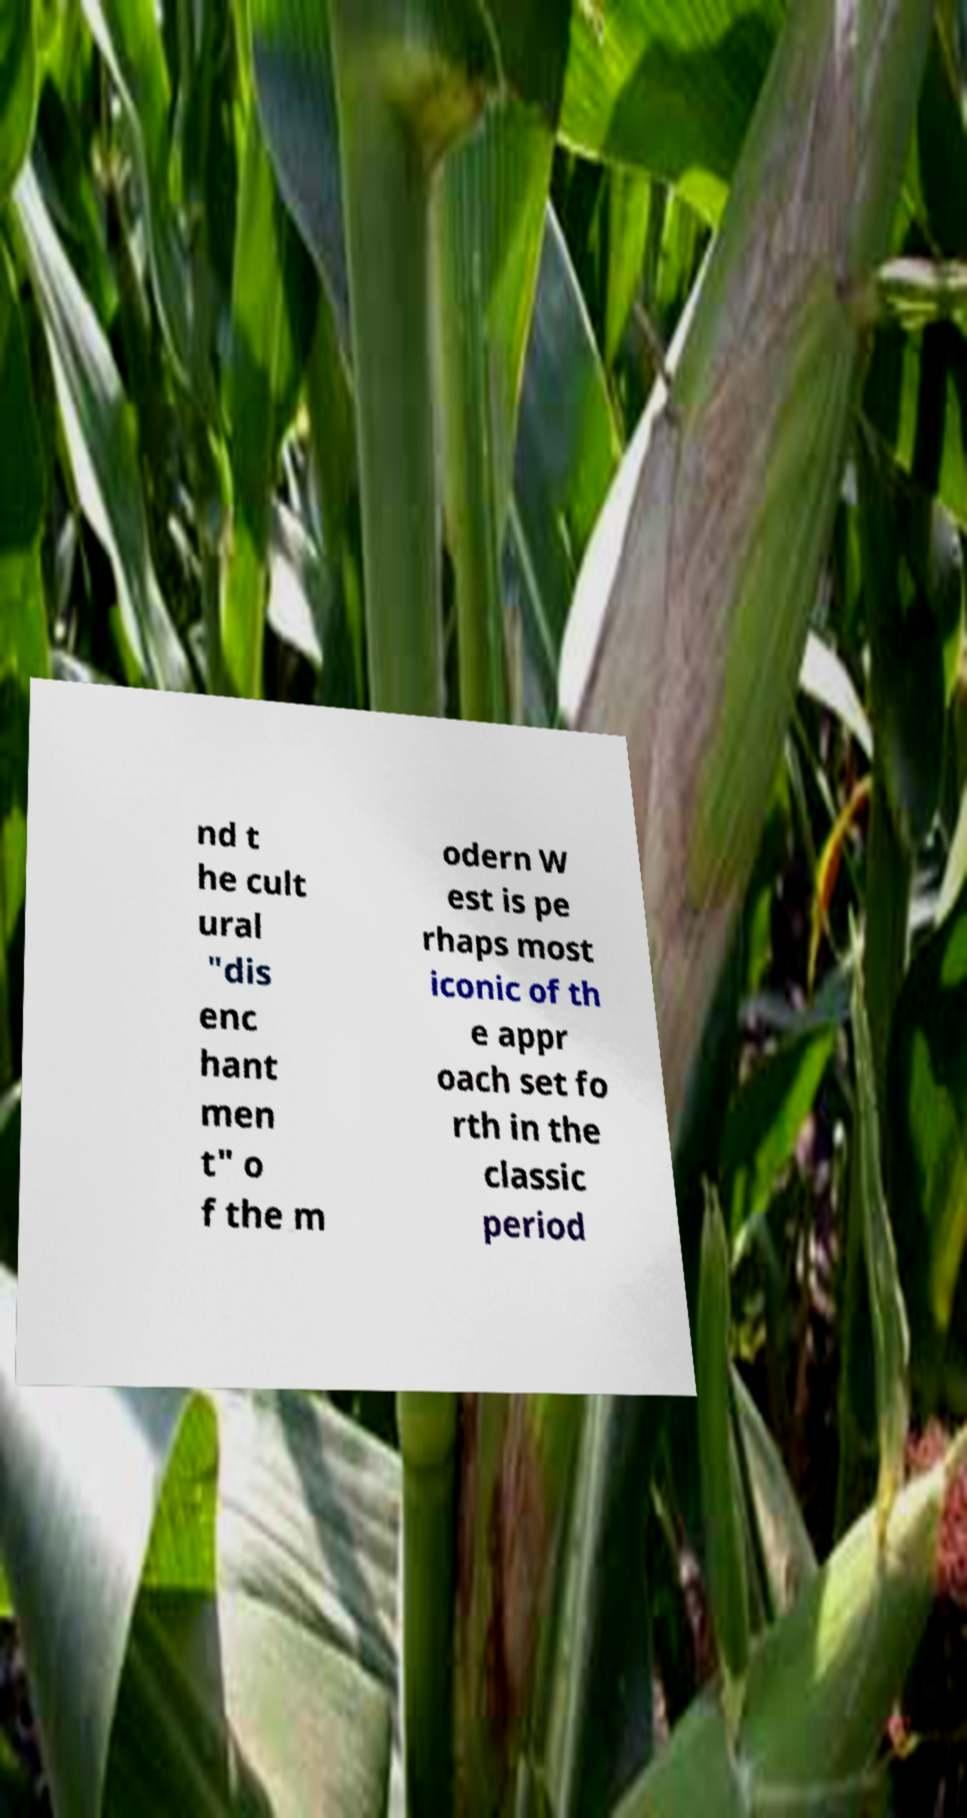For documentation purposes, I need the text within this image transcribed. Could you provide that? nd t he cult ural "dis enc hant men t" o f the m odern W est is pe rhaps most iconic of th e appr oach set fo rth in the classic period 